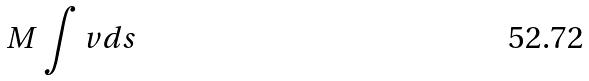<formula> <loc_0><loc_0><loc_500><loc_500>M \int v d s</formula> 